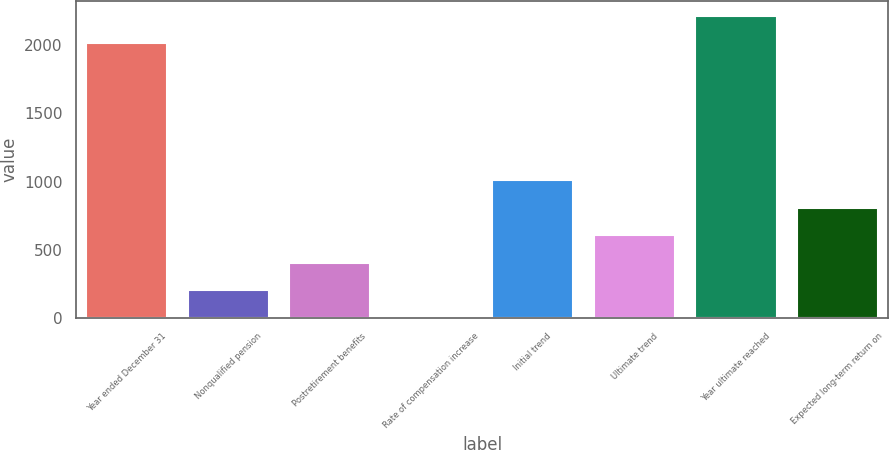Convert chart to OTSL. <chart><loc_0><loc_0><loc_500><loc_500><bar_chart><fcel>Year ended December 31<fcel>Nonqualified pension<fcel>Postretirement benefits<fcel>Rate of compensation increase<fcel>Initial trend<fcel>Ultimate trend<fcel>Year ultimate reached<fcel>Expected long-term return on<nl><fcel>2011<fcel>205.5<fcel>407<fcel>4<fcel>1011.5<fcel>608.5<fcel>2212.5<fcel>810<nl></chart> 